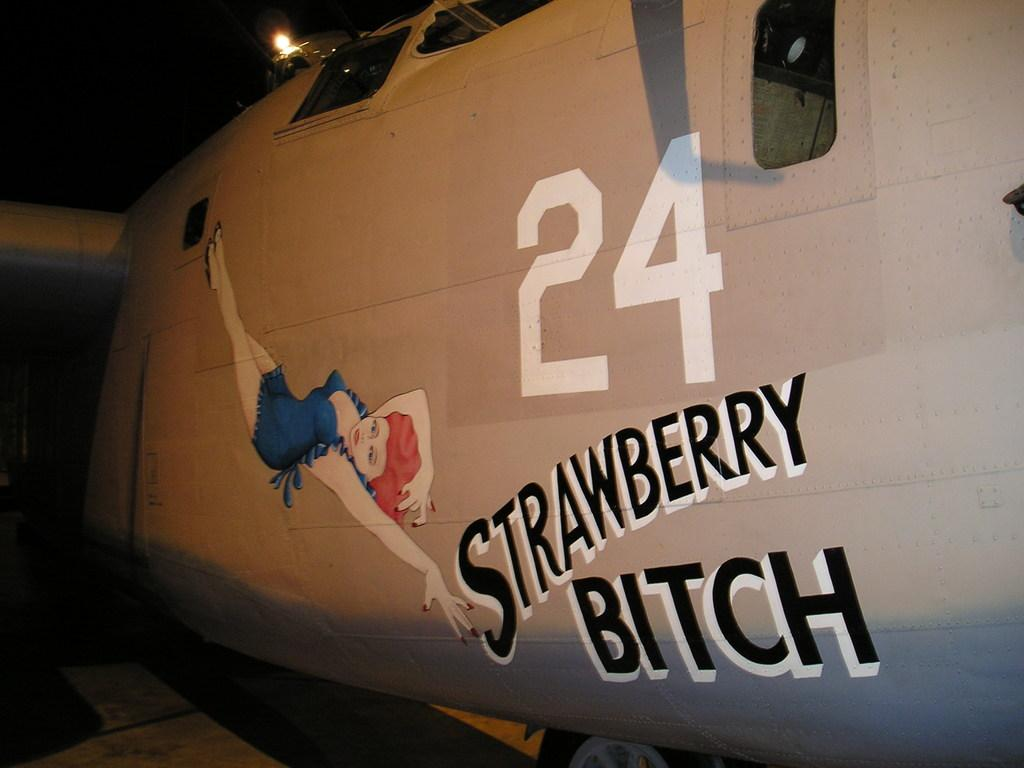<image>
Give a short and clear explanation of the subsequent image. An airplane has the #24 and the words Strawberry B**ch on the side. 